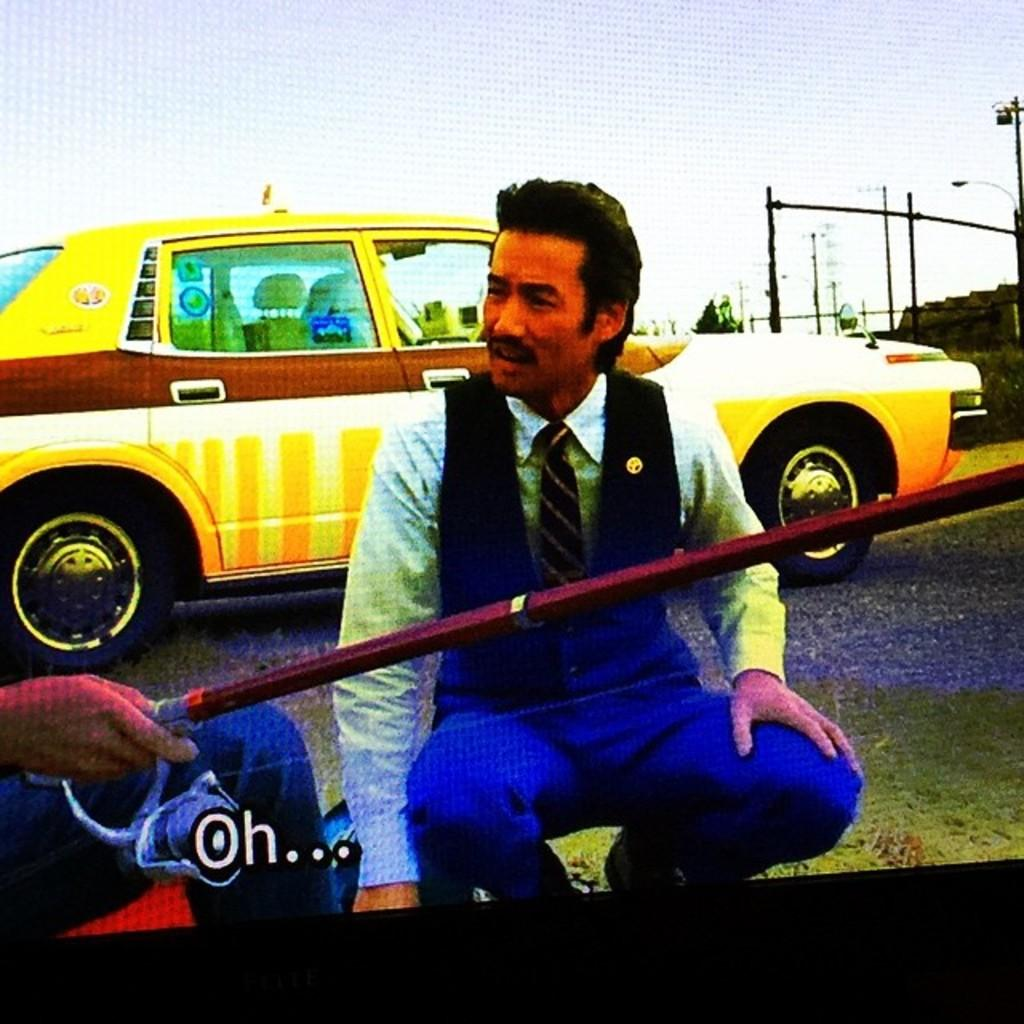<image>
Create a compact narrative representing the image presented. The word written on the screen infront of the male sitting is oh. 